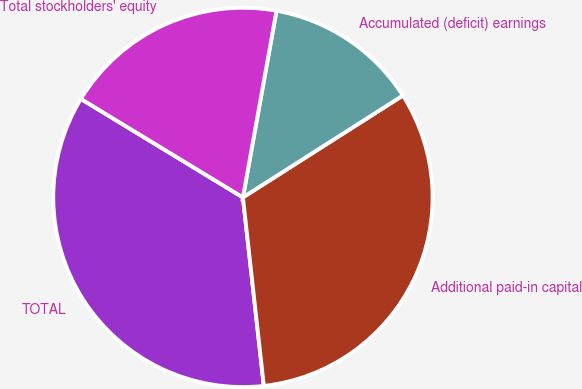Convert chart to OTSL. <chart><loc_0><loc_0><loc_500><loc_500><pie_chart><fcel>TOTAL<fcel>Additional paid-in capital<fcel>Accumulated (deficit) earnings<fcel>Total stockholders' equity<nl><fcel>35.45%<fcel>32.27%<fcel>13.14%<fcel>19.14%<nl></chart> 